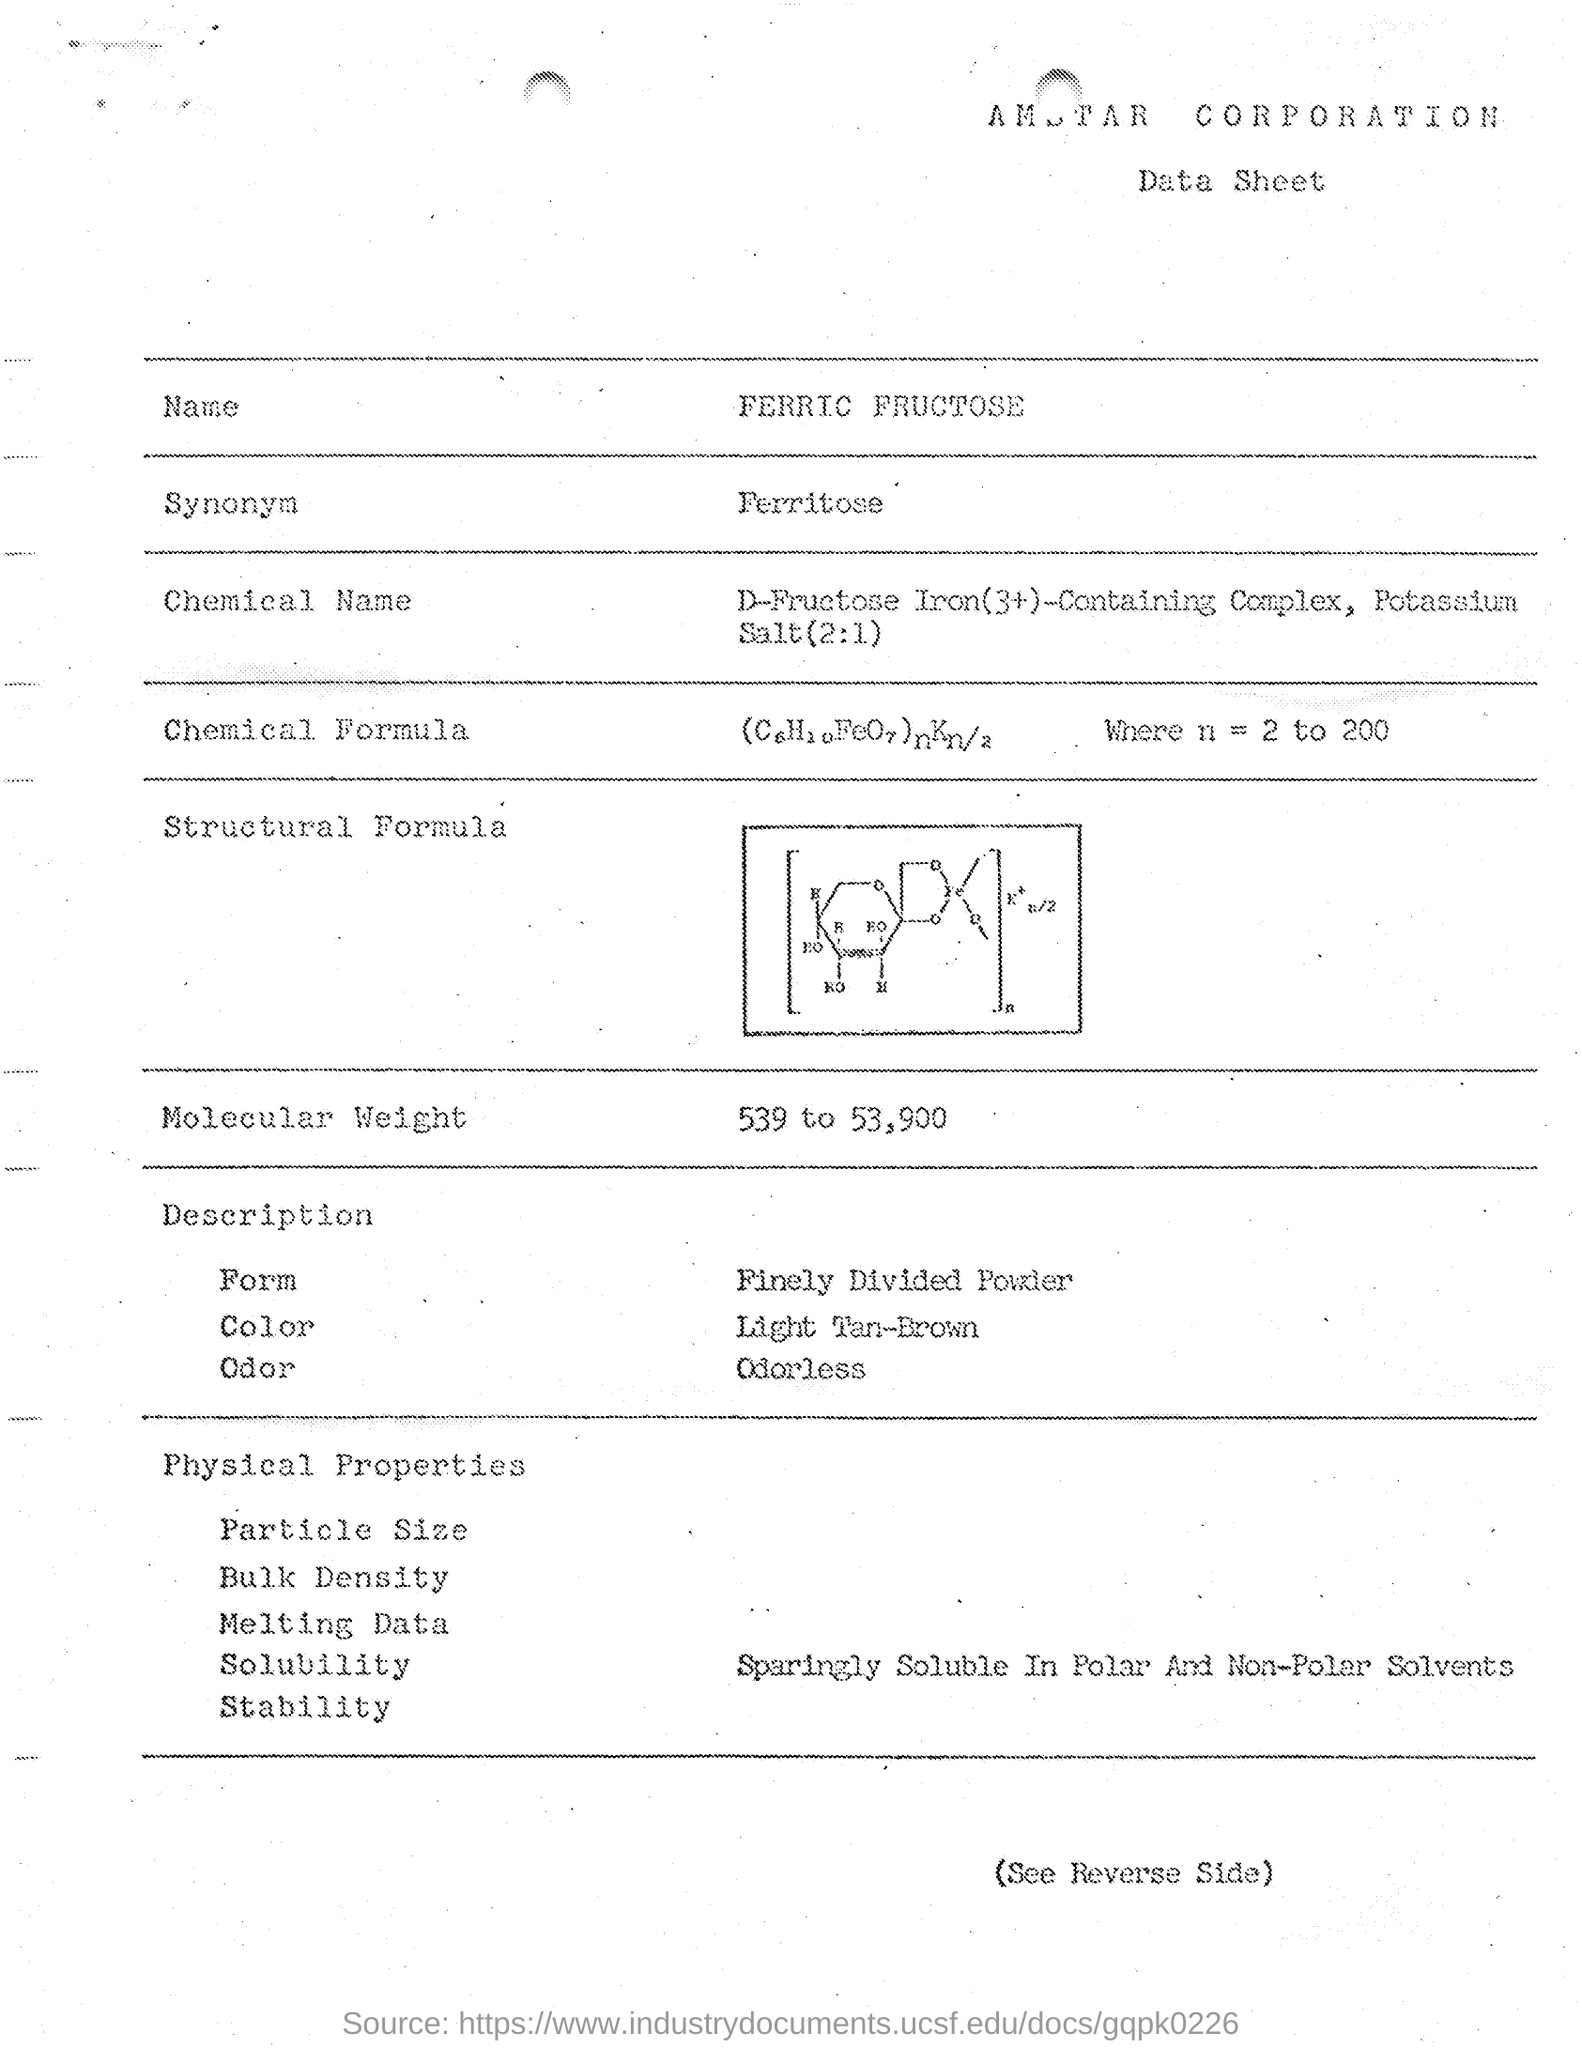What is the Synonym of Ferric Fructose?
Your answer should be very brief. Ferritose. 